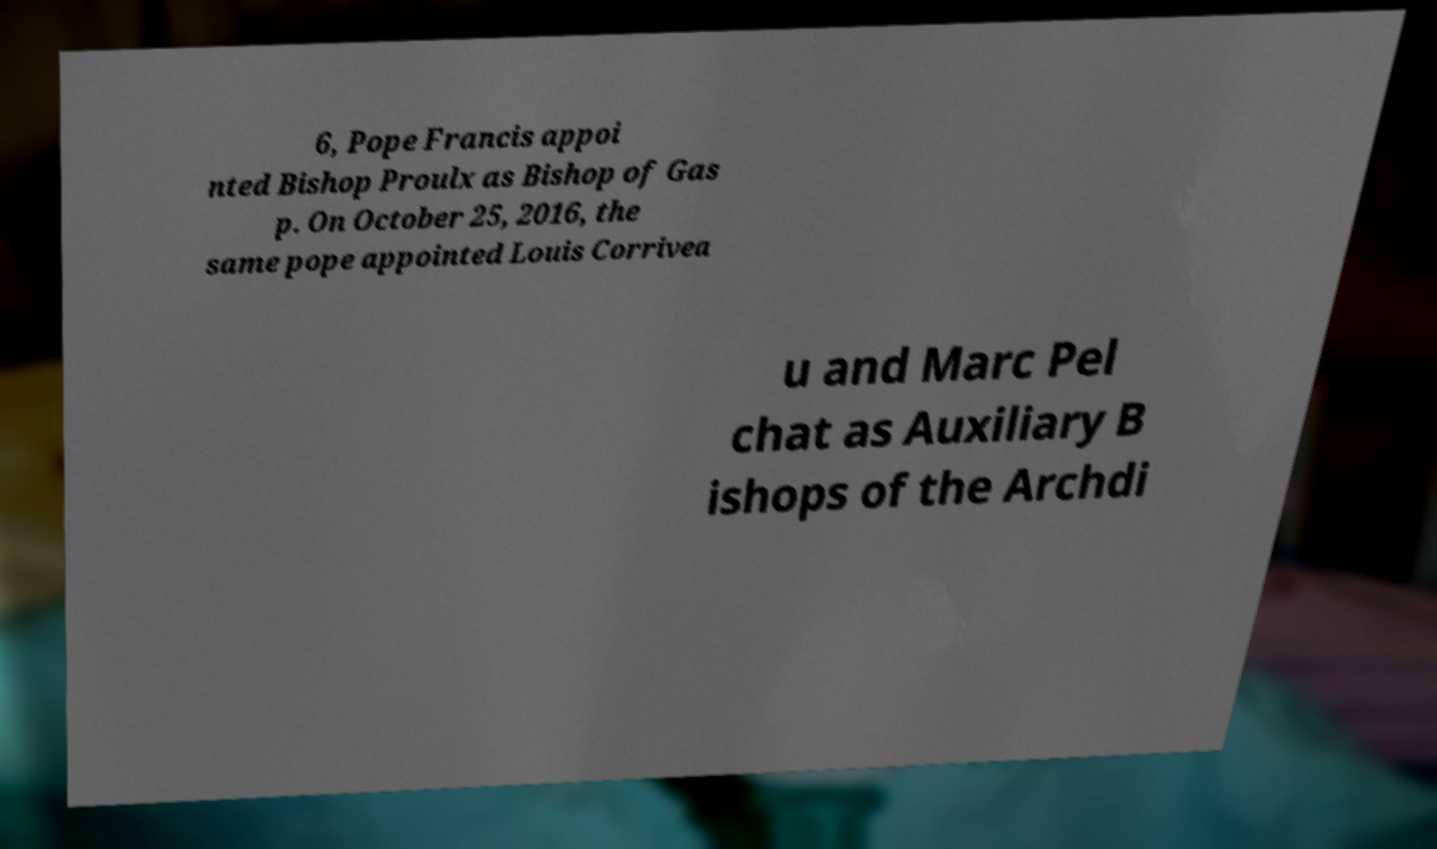Please identify and transcribe the text found in this image. 6, Pope Francis appoi nted Bishop Proulx as Bishop of Gas p. On October 25, 2016, the same pope appointed Louis Corrivea u and Marc Pel chat as Auxiliary B ishops of the Archdi 